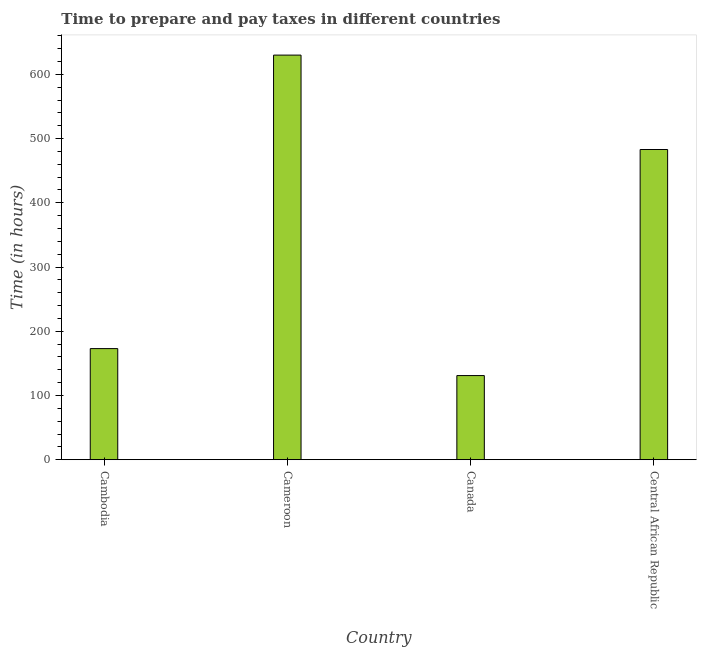Does the graph contain grids?
Your answer should be very brief. No. What is the title of the graph?
Your response must be concise. Time to prepare and pay taxes in different countries. What is the label or title of the X-axis?
Your answer should be compact. Country. What is the label or title of the Y-axis?
Your answer should be compact. Time (in hours). What is the time to prepare and pay taxes in Central African Republic?
Provide a short and direct response. 483. Across all countries, what is the maximum time to prepare and pay taxes?
Give a very brief answer. 630. Across all countries, what is the minimum time to prepare and pay taxes?
Provide a succinct answer. 131. In which country was the time to prepare and pay taxes maximum?
Give a very brief answer. Cameroon. What is the sum of the time to prepare and pay taxes?
Offer a very short reply. 1417. What is the difference between the time to prepare and pay taxes in Cameroon and Central African Republic?
Your answer should be compact. 147. What is the average time to prepare and pay taxes per country?
Provide a succinct answer. 354.25. What is the median time to prepare and pay taxes?
Your answer should be very brief. 328. In how many countries, is the time to prepare and pay taxes greater than 620 hours?
Your answer should be compact. 1. What is the ratio of the time to prepare and pay taxes in Cambodia to that in Cameroon?
Make the answer very short. 0.28. What is the difference between the highest and the second highest time to prepare and pay taxes?
Provide a succinct answer. 147. Is the sum of the time to prepare and pay taxes in Cameroon and Canada greater than the maximum time to prepare and pay taxes across all countries?
Your answer should be very brief. Yes. What is the difference between the highest and the lowest time to prepare and pay taxes?
Ensure brevity in your answer.  499. In how many countries, is the time to prepare and pay taxes greater than the average time to prepare and pay taxes taken over all countries?
Ensure brevity in your answer.  2. How many bars are there?
Provide a short and direct response. 4. Are all the bars in the graph horizontal?
Your answer should be very brief. No. Are the values on the major ticks of Y-axis written in scientific E-notation?
Offer a very short reply. No. What is the Time (in hours) of Cambodia?
Make the answer very short. 173. What is the Time (in hours) in Cameroon?
Provide a succinct answer. 630. What is the Time (in hours) of Canada?
Your answer should be very brief. 131. What is the Time (in hours) in Central African Republic?
Your response must be concise. 483. What is the difference between the Time (in hours) in Cambodia and Cameroon?
Provide a short and direct response. -457. What is the difference between the Time (in hours) in Cambodia and Central African Republic?
Your answer should be compact. -310. What is the difference between the Time (in hours) in Cameroon and Canada?
Make the answer very short. 499. What is the difference between the Time (in hours) in Cameroon and Central African Republic?
Your response must be concise. 147. What is the difference between the Time (in hours) in Canada and Central African Republic?
Provide a succinct answer. -352. What is the ratio of the Time (in hours) in Cambodia to that in Cameroon?
Offer a terse response. 0.28. What is the ratio of the Time (in hours) in Cambodia to that in Canada?
Your answer should be very brief. 1.32. What is the ratio of the Time (in hours) in Cambodia to that in Central African Republic?
Your response must be concise. 0.36. What is the ratio of the Time (in hours) in Cameroon to that in Canada?
Offer a very short reply. 4.81. What is the ratio of the Time (in hours) in Cameroon to that in Central African Republic?
Offer a terse response. 1.3. What is the ratio of the Time (in hours) in Canada to that in Central African Republic?
Make the answer very short. 0.27. 